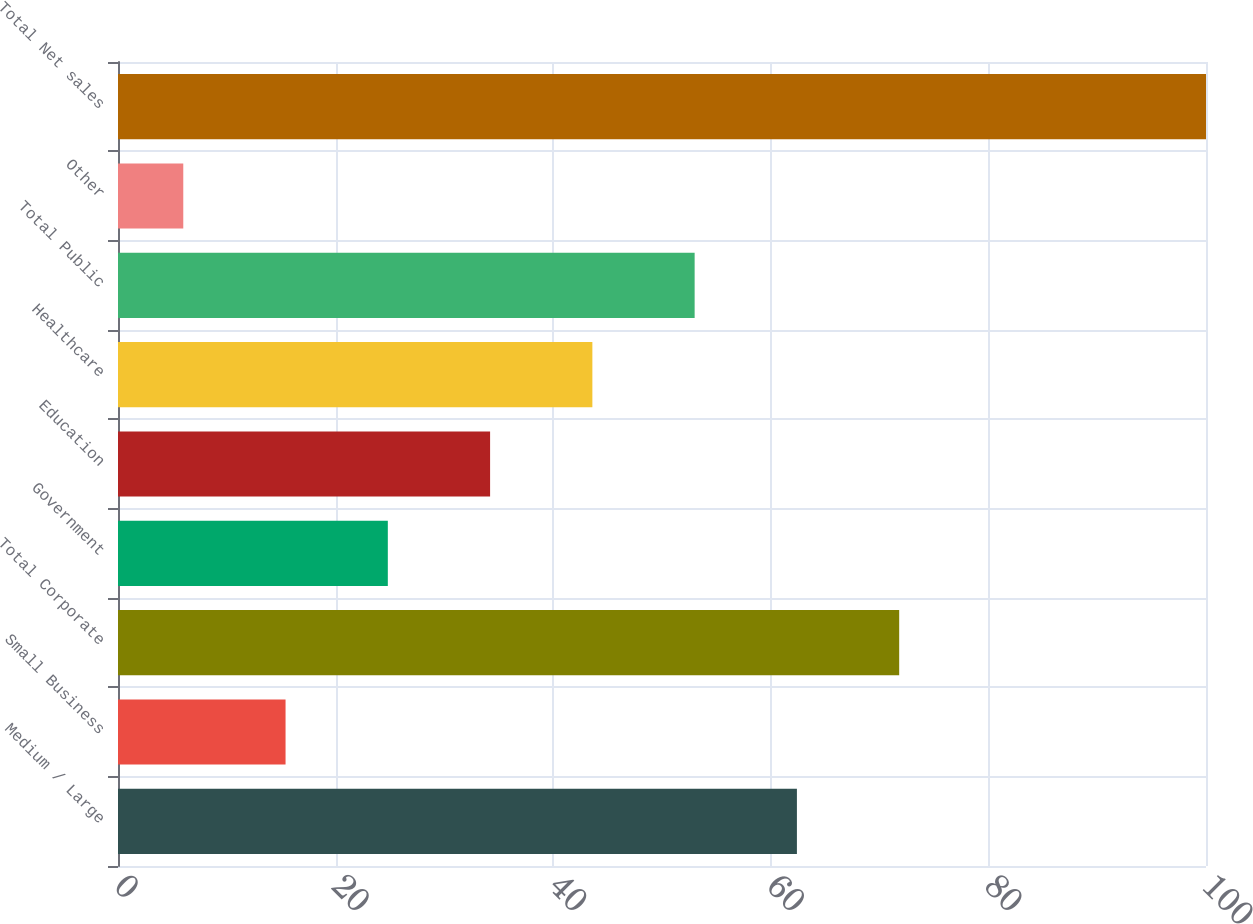<chart> <loc_0><loc_0><loc_500><loc_500><bar_chart><fcel>Medium / Large<fcel>Small Business<fcel>Total Corporate<fcel>Government<fcel>Education<fcel>Healthcare<fcel>Total Public<fcel>Other<fcel>Total Net sales<nl><fcel>62.4<fcel>15.4<fcel>71.8<fcel>24.8<fcel>34.2<fcel>43.6<fcel>53<fcel>6<fcel>100<nl></chart> 